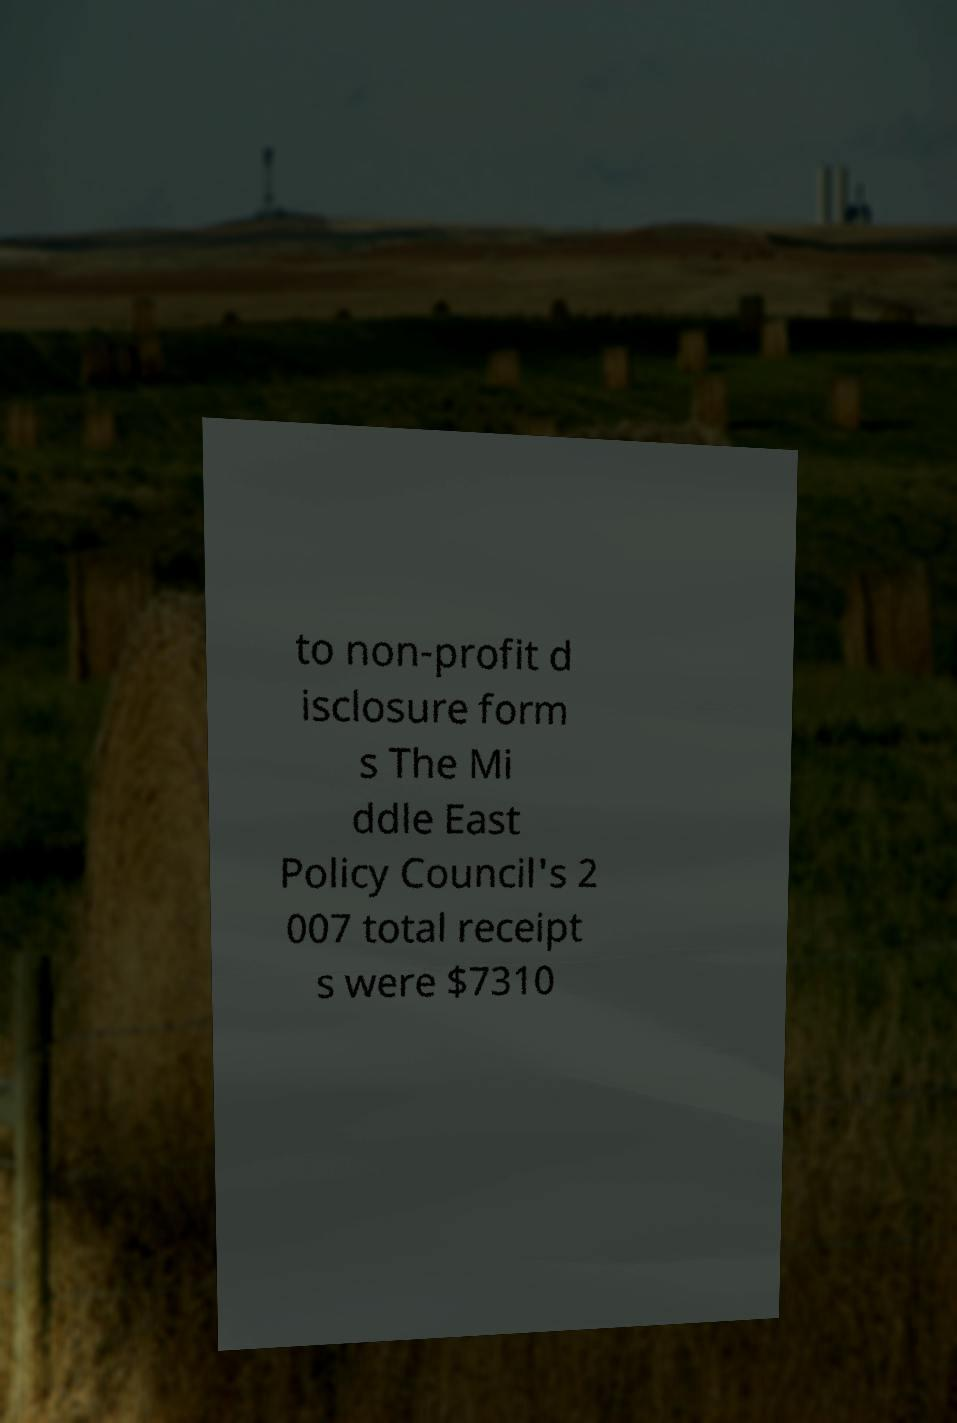Could you assist in decoding the text presented in this image and type it out clearly? to non-profit d isclosure form s The Mi ddle East Policy Council's 2 007 total receipt s were $7310 